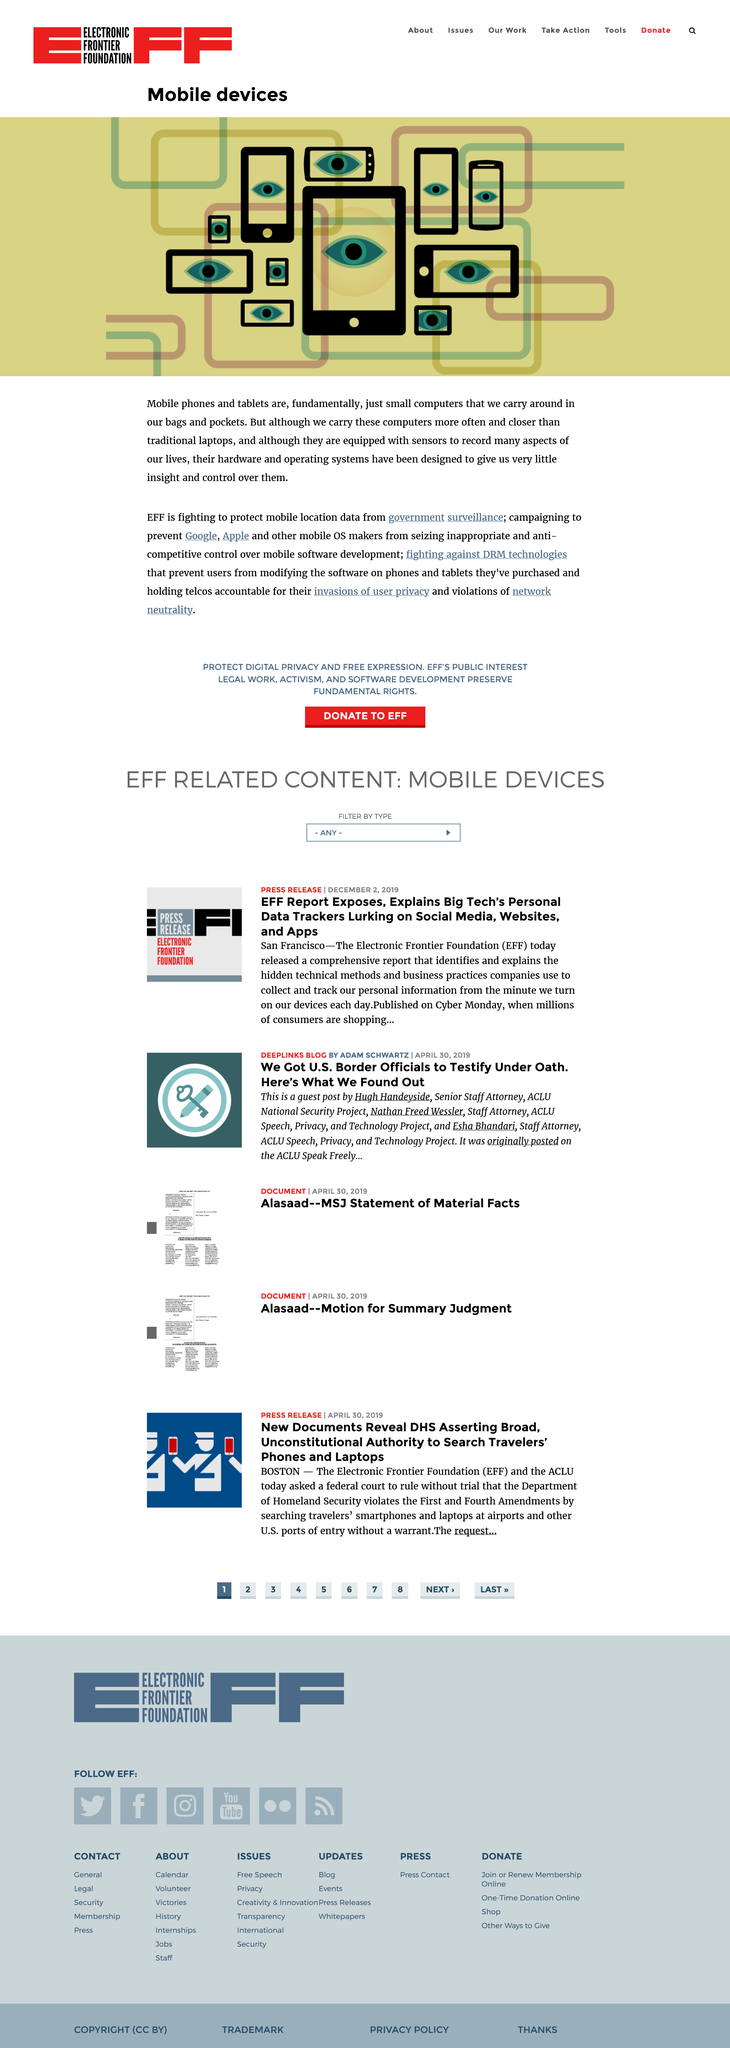Specify some key components in this picture. The entity responsible for holding telcos accountable for their invasions of user privacy is the Electronic Frontier Foundation (EFF). The Electronic Frontier Foundation (EFF) is an entity that is fighting against Digital Rights Management (DRM) technologies that prevent users from modifying the software on phones. 